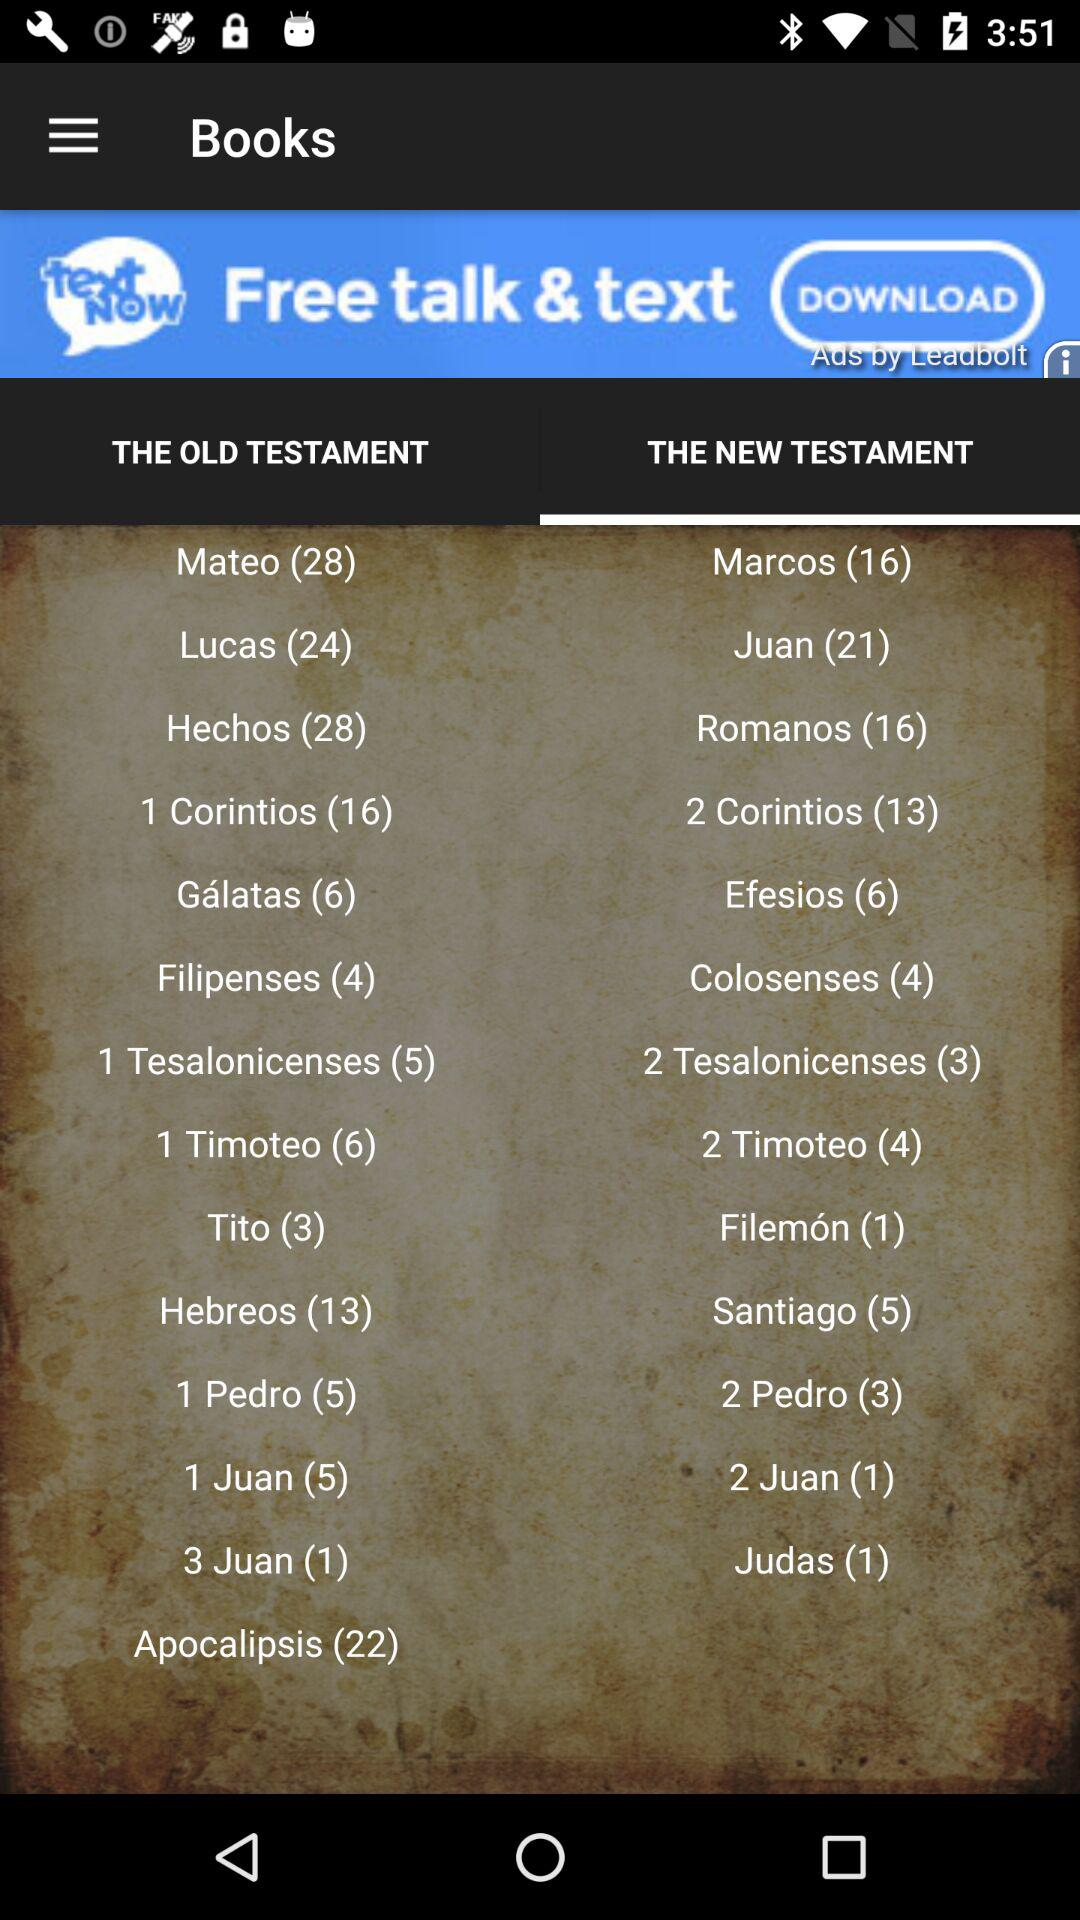Which tab is selected? The selected tab is "THE NEW TESTAMENT". 